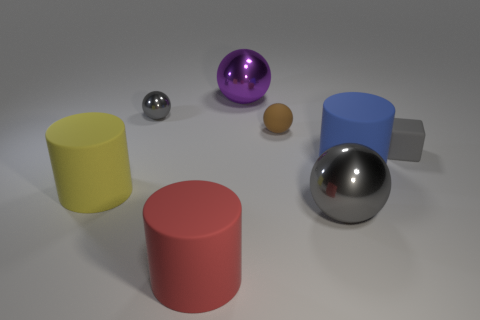Is the color of the tiny shiny sphere the same as the rubber block?
Offer a very short reply. Yes. What is the size of the cube that is the same color as the tiny metallic thing?
Give a very brief answer. Small. Are there any tiny rubber objects that are in front of the tiny matte thing behind the tiny object right of the big blue matte cylinder?
Your response must be concise. Yes. What number of tiny metal balls are to the right of the tiny shiny object?
Offer a terse response. 0. What number of small metallic spheres are the same color as the small cube?
Your answer should be compact. 1. How many things are either large shiny things that are in front of the tiny gray rubber thing or matte things left of the tiny metallic thing?
Make the answer very short. 2. Is the number of tiny brown rubber spheres greater than the number of large brown balls?
Your response must be concise. Yes. The matte object that is right of the big blue cylinder is what color?
Your response must be concise. Gray. Does the yellow matte thing have the same shape as the large red object?
Your response must be concise. Yes. There is a thing that is in front of the gray rubber thing and behind the big yellow rubber object; what is its color?
Your answer should be compact. Blue. 